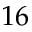<formula> <loc_0><loc_0><loc_500><loc_500>1 6</formula> 